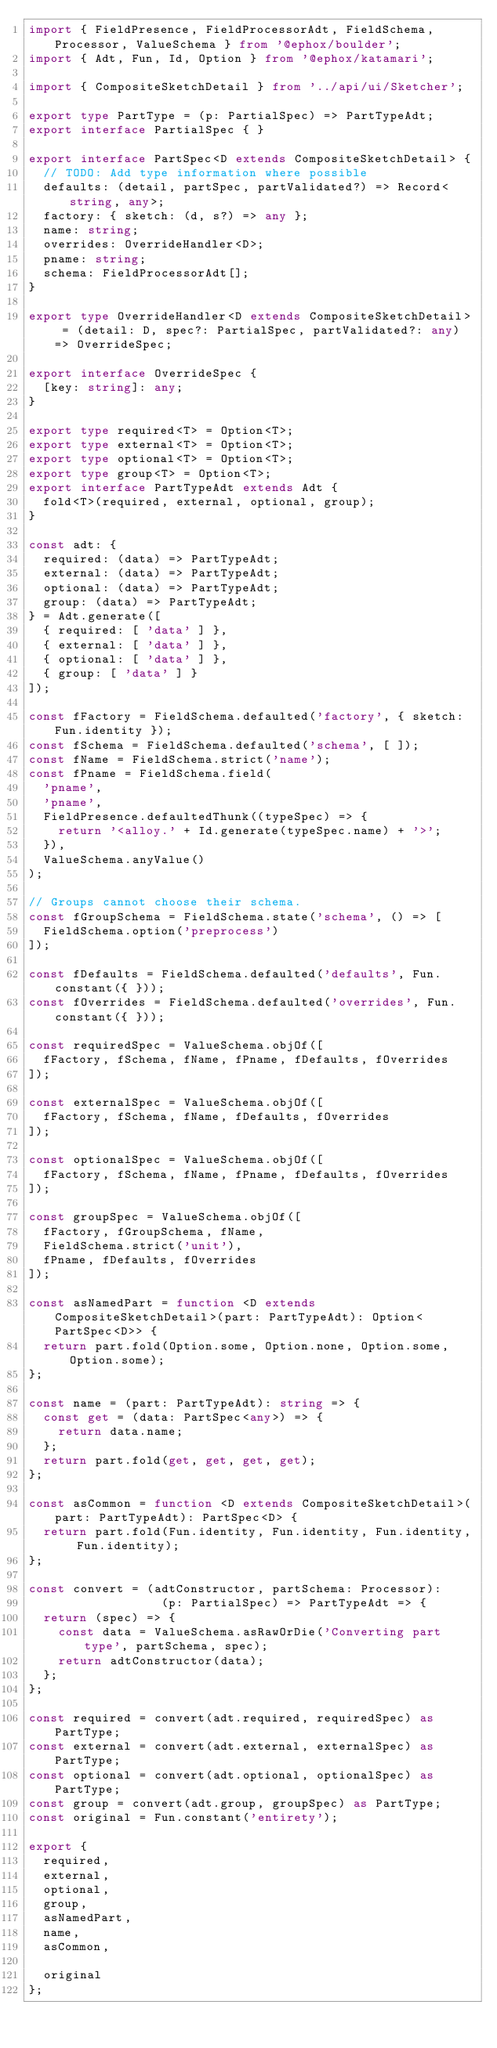Convert code to text. <code><loc_0><loc_0><loc_500><loc_500><_TypeScript_>import { FieldPresence, FieldProcessorAdt, FieldSchema, Processor, ValueSchema } from '@ephox/boulder';
import { Adt, Fun, Id, Option } from '@ephox/katamari';

import { CompositeSketchDetail } from '../api/ui/Sketcher';

export type PartType = (p: PartialSpec) => PartTypeAdt;
export interface PartialSpec { }

export interface PartSpec<D extends CompositeSketchDetail> {
  // TODO: Add type information where possible
  defaults: (detail, partSpec, partValidated?) => Record<string, any>;
  factory: { sketch: (d, s?) => any };
  name: string;
  overrides: OverrideHandler<D>;
  pname: string;
  schema: FieldProcessorAdt[];
}

export type OverrideHandler<D extends CompositeSketchDetail> = (detail: D, spec?: PartialSpec, partValidated?: any) => OverrideSpec;

export interface OverrideSpec {
  [key: string]: any;
}

export type required<T> = Option<T>;
export type external<T> = Option<T>;
export type optional<T> = Option<T>;
export type group<T> = Option<T>;
export interface PartTypeAdt extends Adt {
  fold<T>(required, external, optional, group);
}

const adt: {
  required: (data) => PartTypeAdt;
  external: (data) => PartTypeAdt;
  optional: (data) => PartTypeAdt;
  group: (data) => PartTypeAdt;
} = Adt.generate([
  { required: [ 'data' ] },
  { external: [ 'data' ] },
  { optional: [ 'data' ] },
  { group: [ 'data' ] }
]);

const fFactory = FieldSchema.defaulted('factory', { sketch: Fun.identity });
const fSchema = FieldSchema.defaulted('schema', [ ]);
const fName = FieldSchema.strict('name');
const fPname = FieldSchema.field(
  'pname',
  'pname',
  FieldPresence.defaultedThunk((typeSpec) => {
    return '<alloy.' + Id.generate(typeSpec.name) + '>';
  }),
  ValueSchema.anyValue()
);

// Groups cannot choose their schema.
const fGroupSchema = FieldSchema.state('schema', () => [
  FieldSchema.option('preprocess')
]);

const fDefaults = FieldSchema.defaulted('defaults', Fun.constant({ }));
const fOverrides = FieldSchema.defaulted('overrides', Fun.constant({ }));

const requiredSpec = ValueSchema.objOf([
  fFactory, fSchema, fName, fPname, fDefaults, fOverrides
]);

const externalSpec = ValueSchema.objOf([
  fFactory, fSchema, fName, fDefaults, fOverrides
]);

const optionalSpec = ValueSchema.objOf([
  fFactory, fSchema, fName, fPname, fDefaults, fOverrides
]);

const groupSpec = ValueSchema.objOf([
  fFactory, fGroupSchema, fName,
  FieldSchema.strict('unit'),
  fPname, fDefaults, fOverrides
]);

const asNamedPart = function <D extends CompositeSketchDetail>(part: PartTypeAdt): Option<PartSpec<D>> {
  return part.fold(Option.some, Option.none, Option.some, Option.some);
};

const name = (part: PartTypeAdt): string => {
  const get = (data: PartSpec<any>) => {
    return data.name;
  };
  return part.fold(get, get, get, get);
};

const asCommon = function <D extends CompositeSketchDetail>(part: PartTypeAdt): PartSpec<D> {
  return part.fold(Fun.identity, Fun.identity, Fun.identity, Fun.identity);
};

const convert = (adtConstructor, partSchema: Processor):
                  (p: PartialSpec) => PartTypeAdt => {
  return (spec) => {
    const data = ValueSchema.asRawOrDie('Converting part type', partSchema, spec);
    return adtConstructor(data);
  };
};

const required = convert(adt.required, requiredSpec) as PartType;
const external = convert(adt.external, externalSpec) as PartType;
const optional = convert(adt.optional, optionalSpec) as PartType;
const group = convert(adt.group, groupSpec) as PartType;
const original = Fun.constant('entirety');

export {
  required,
  external,
  optional,
  group,
  asNamedPart,
  name,
  asCommon,

  original
};</code> 